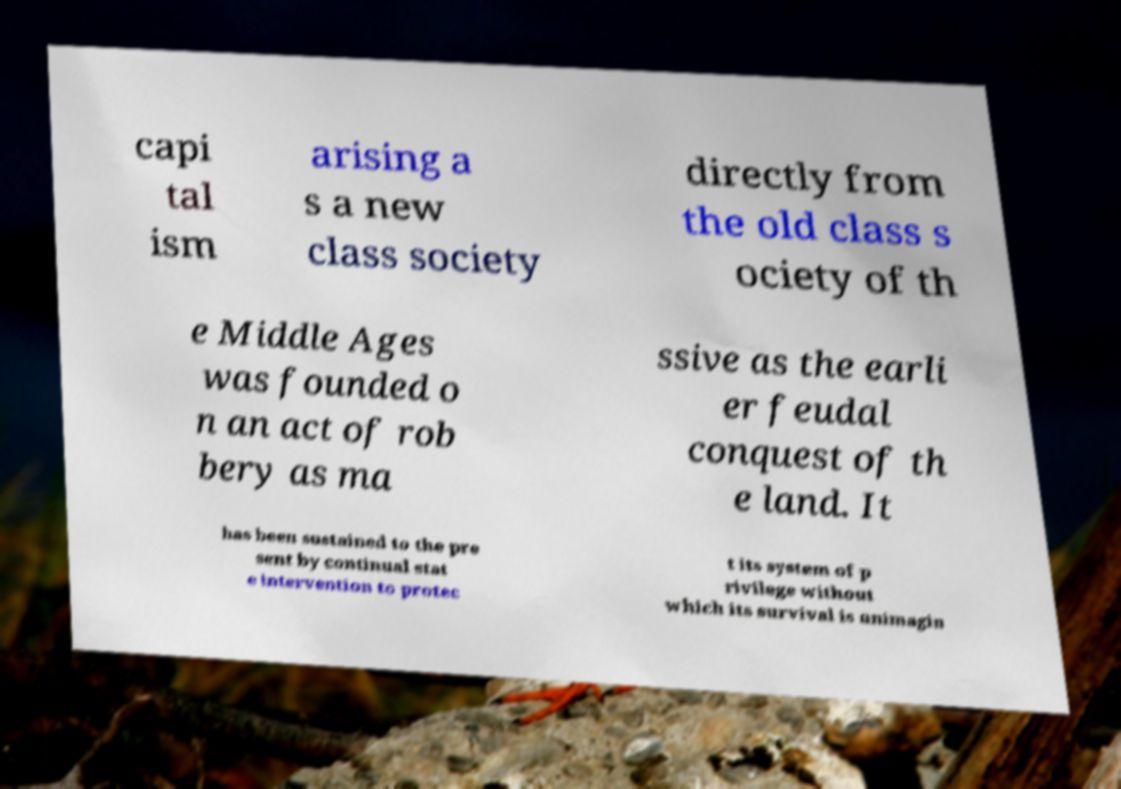Can you accurately transcribe the text from the provided image for me? capi tal ism arising a s a new class society directly from the old class s ociety of th e Middle Ages was founded o n an act of rob bery as ma ssive as the earli er feudal conquest of th e land. It has been sustained to the pre sent by continual stat e intervention to protec t its system of p rivilege without which its survival is unimagin 